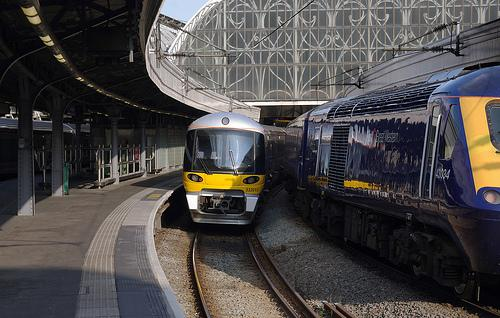Question: why is there a train?
Choices:
A. For commuters.
B. For students.
C. Transportation.
D. For supplies.
Answer with the letter. Answer: C Question: when was the photo taken?
Choices:
A. Afternoon.
B. Morning.
C. Breakfast time.
D. Dinner time.
Answer with the letter. Answer: A Question: what color is the mirror?
Choices:
A. Gray.
B. Clear.
C. Silver.
D. Red.
Answer with the letter. Answer: C Question: where is the train going?
Choices:
A. To the city.
B. North.
C. To the plant.
D. To the river.
Answer with the letter. Answer: B 